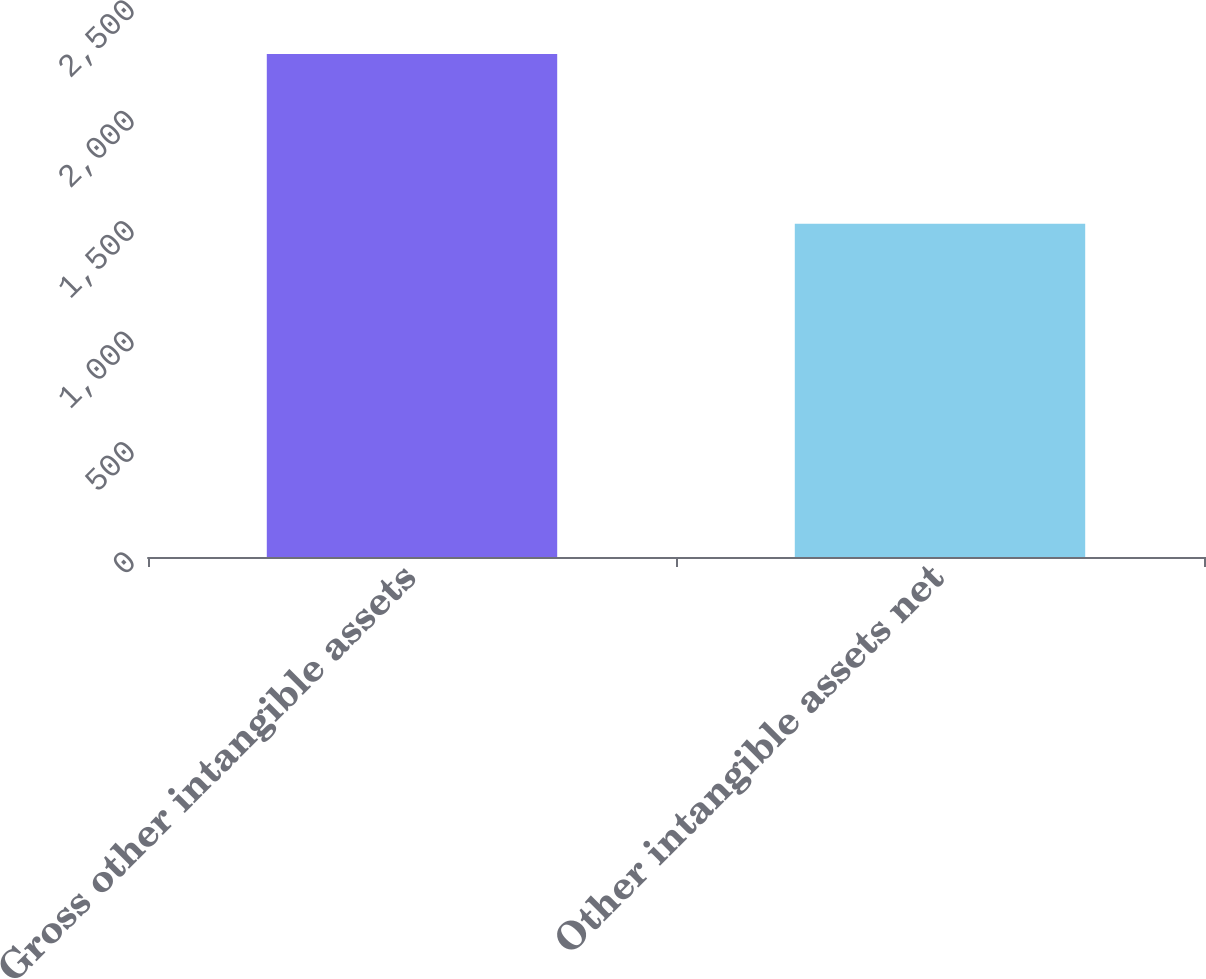Convert chart to OTSL. <chart><loc_0><loc_0><loc_500><loc_500><bar_chart><fcel>Gross other intangible assets<fcel>Other intangible assets net<nl><fcel>2278<fcel>1509<nl></chart> 